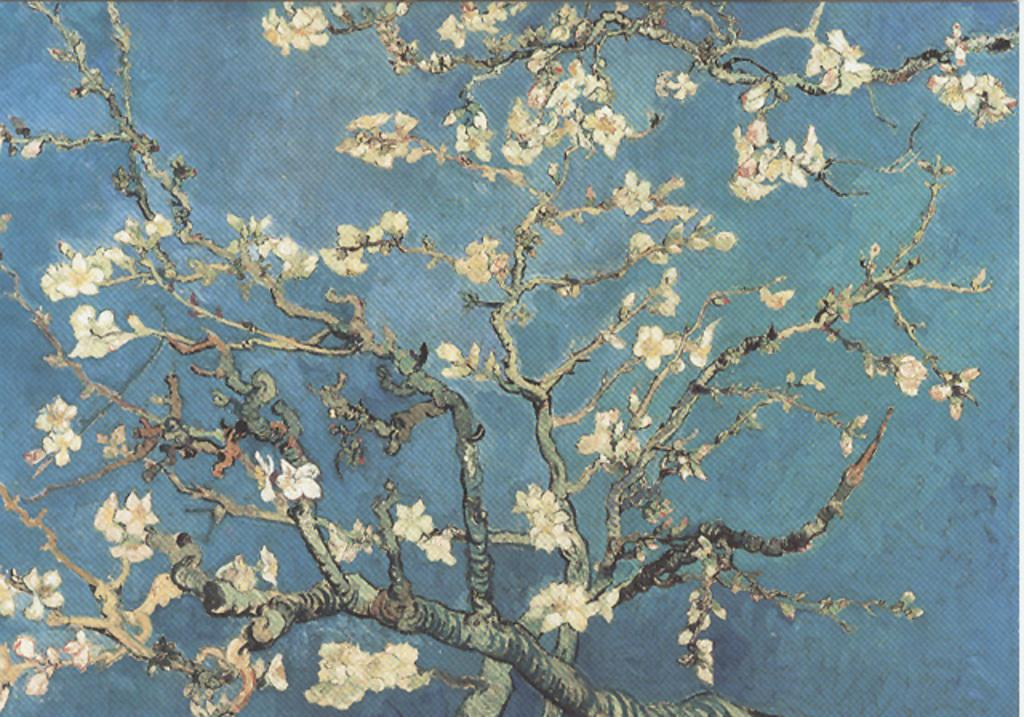What is depicted in the painting in the image? There is a painting of a tree in the image. Where is the painting located? The painting is on a carpet. What type of poison is being used to clean the carpet in the image? There is no mention of poison or cleaning in the image; it only features a painting of a tree on a carpet. 